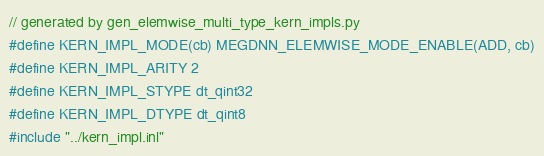<code> <loc_0><loc_0><loc_500><loc_500><_Cuda_>// generated by gen_elemwise_multi_type_kern_impls.py
#define KERN_IMPL_MODE(cb) MEGDNN_ELEMWISE_MODE_ENABLE(ADD, cb)
#define KERN_IMPL_ARITY 2
#define KERN_IMPL_STYPE dt_qint32
#define KERN_IMPL_DTYPE dt_qint8
#include "../kern_impl.inl"
</code> 